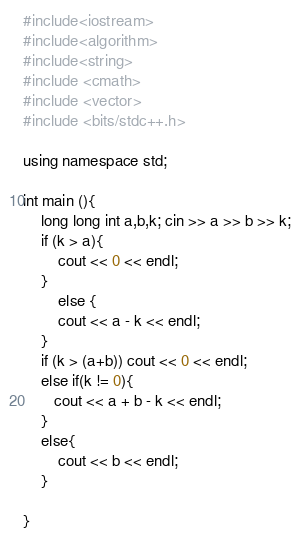Convert code to text. <code><loc_0><loc_0><loc_500><loc_500><_C++_>#include<iostream>
#include<algorithm>
#include<string>
#include <cmath>
#include <vector>
#include <bits/stdc++.h>

using namespace std;

int main (){
    long long int a,b,k; cin >> a >> b >> k;
    if (k > a){
        cout << 0 << endl;
    }
        else {
        cout << a - k << endl;
    }
    if (k > (a+b)) cout << 0 << endl;
    else if(k != 0){
       cout << a + b - k << endl;
    }
    else{
        cout << b << endl;
    }
    
}</code> 